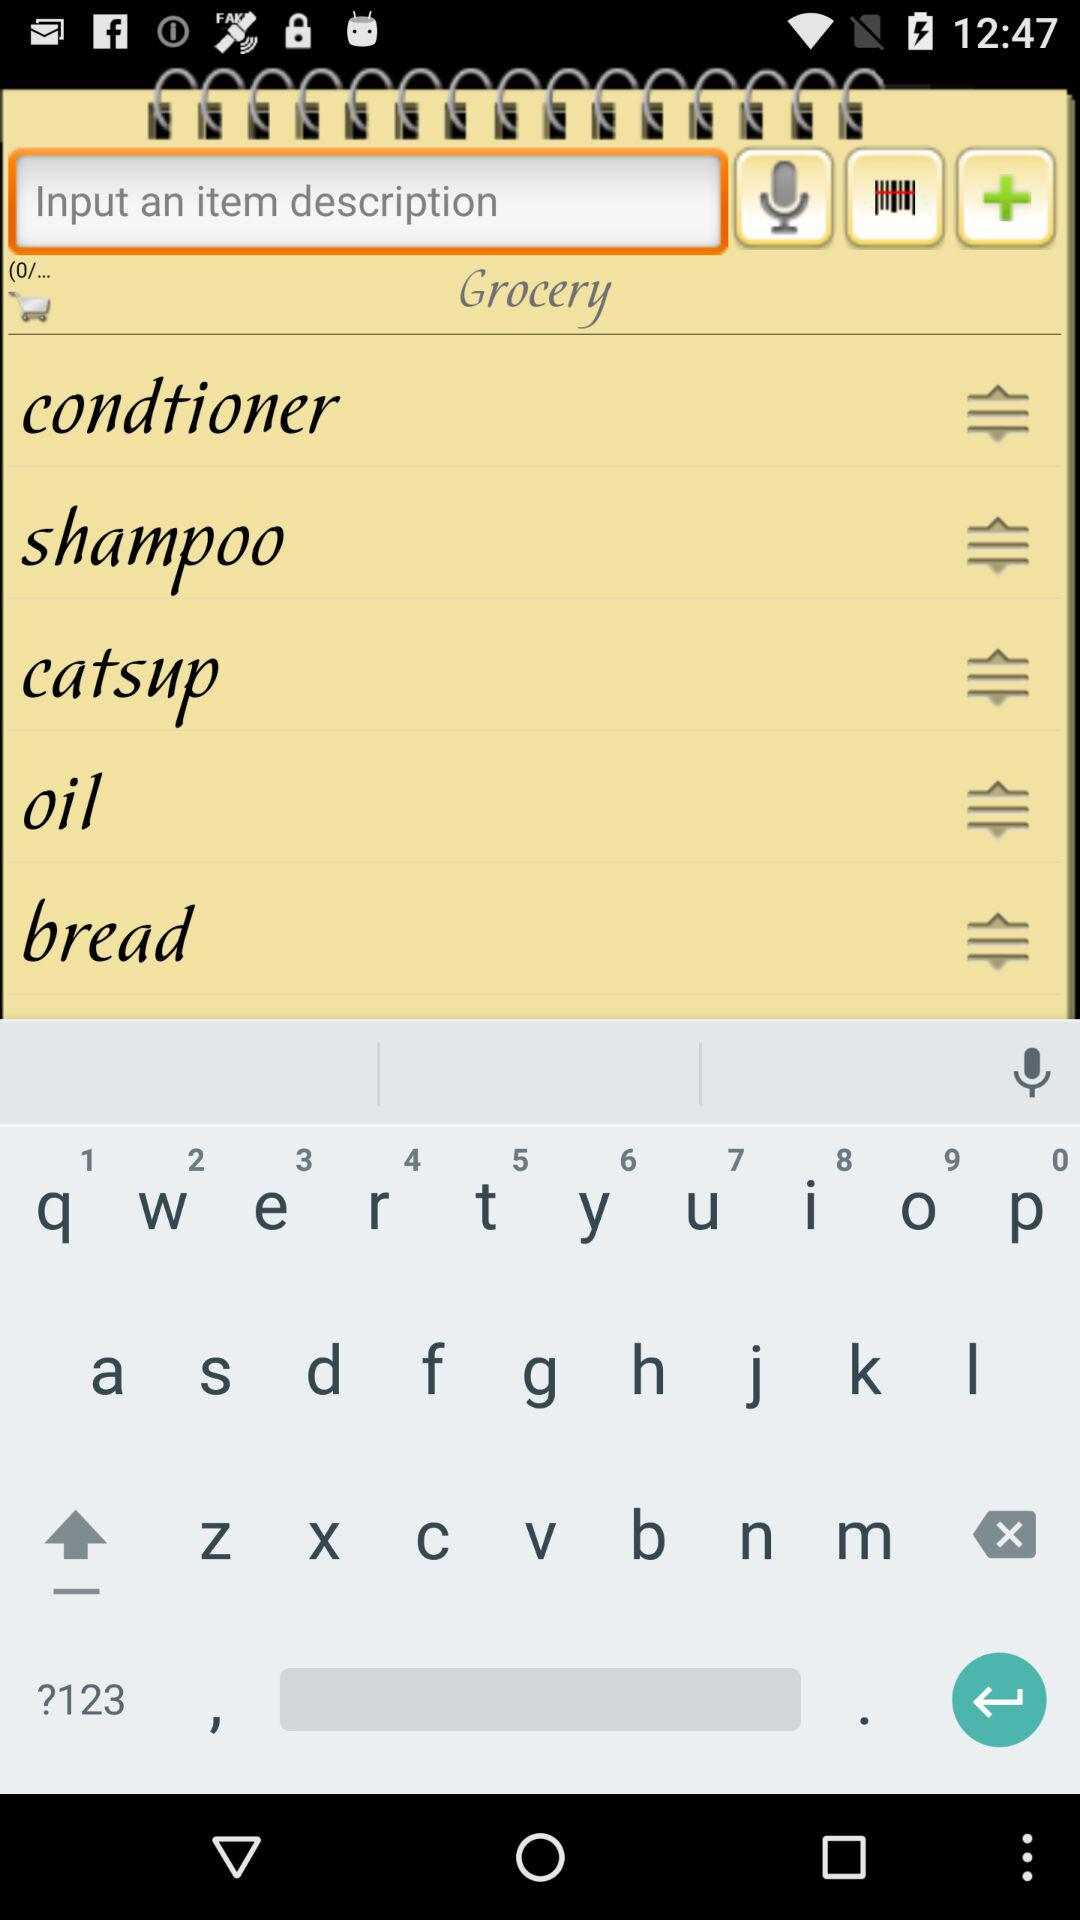How many items are in the shopping cart?
Answer the question using a single word or phrase. 5 